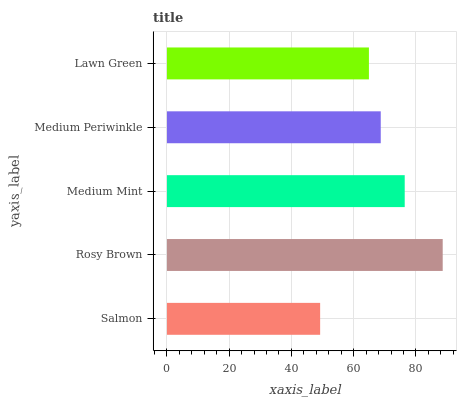Is Salmon the minimum?
Answer yes or no. Yes. Is Rosy Brown the maximum?
Answer yes or no. Yes. Is Medium Mint the minimum?
Answer yes or no. No. Is Medium Mint the maximum?
Answer yes or no. No. Is Rosy Brown greater than Medium Mint?
Answer yes or no. Yes. Is Medium Mint less than Rosy Brown?
Answer yes or no. Yes. Is Medium Mint greater than Rosy Brown?
Answer yes or no. No. Is Rosy Brown less than Medium Mint?
Answer yes or no. No. Is Medium Periwinkle the high median?
Answer yes or no. Yes. Is Medium Periwinkle the low median?
Answer yes or no. Yes. Is Rosy Brown the high median?
Answer yes or no. No. Is Salmon the low median?
Answer yes or no. No. 